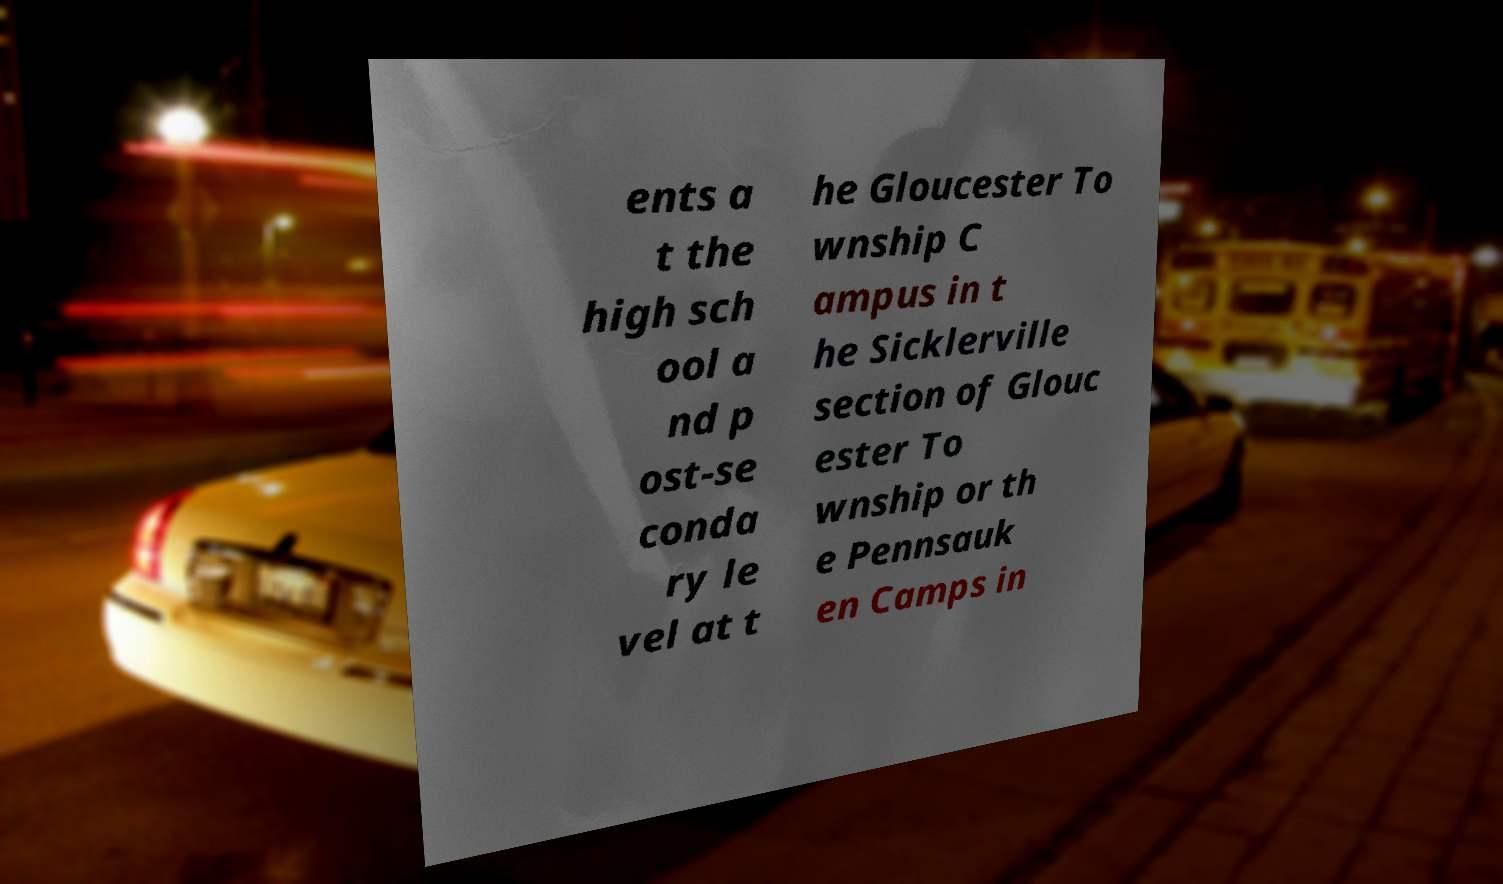There's text embedded in this image that I need extracted. Can you transcribe it verbatim? ents a t the high sch ool a nd p ost-se conda ry le vel at t he Gloucester To wnship C ampus in t he Sicklerville section of Glouc ester To wnship or th e Pennsauk en Camps in 